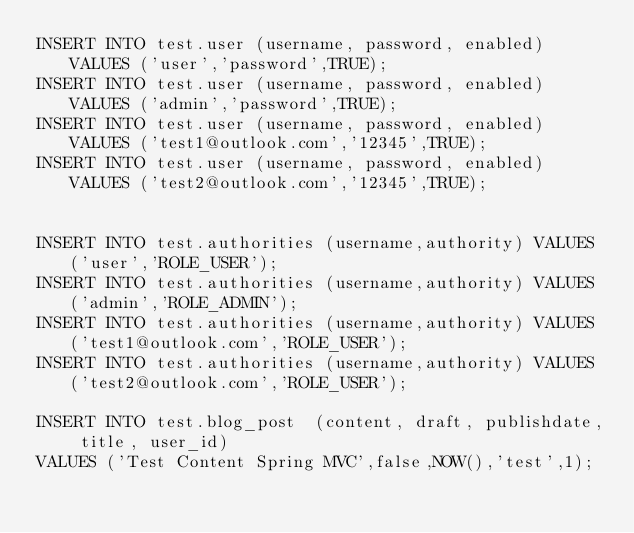<code> <loc_0><loc_0><loc_500><loc_500><_SQL_>INSERT INTO test.user (username, password, enabled) VALUES ('user','password',TRUE);
INSERT INTO test.user (username, password, enabled) VALUES ('admin','password',TRUE);
INSERT INTO test.user (username, password, enabled) VALUES ('test1@outlook.com','12345',TRUE);
INSERT INTO test.user (username, password, enabled) VALUES ('test2@outlook.com','12345',TRUE);


INSERT INTO test.authorities (username,authority) VALUES ('user','ROLE_USER');
INSERT INTO test.authorities (username,authority) VALUES ('admin','ROLE_ADMIN');
INSERT INTO test.authorities (username,authority) VALUES ('test1@outlook.com','ROLE_USER');
INSERT INTO test.authorities (username,authority) VALUES ('test2@outlook.com','ROLE_USER');

INSERT INTO test.blog_post  (content, draft, publishdate, title, user_id)
VALUES ('Test Content Spring MVC',false,NOW(),'test',1);
</code> 